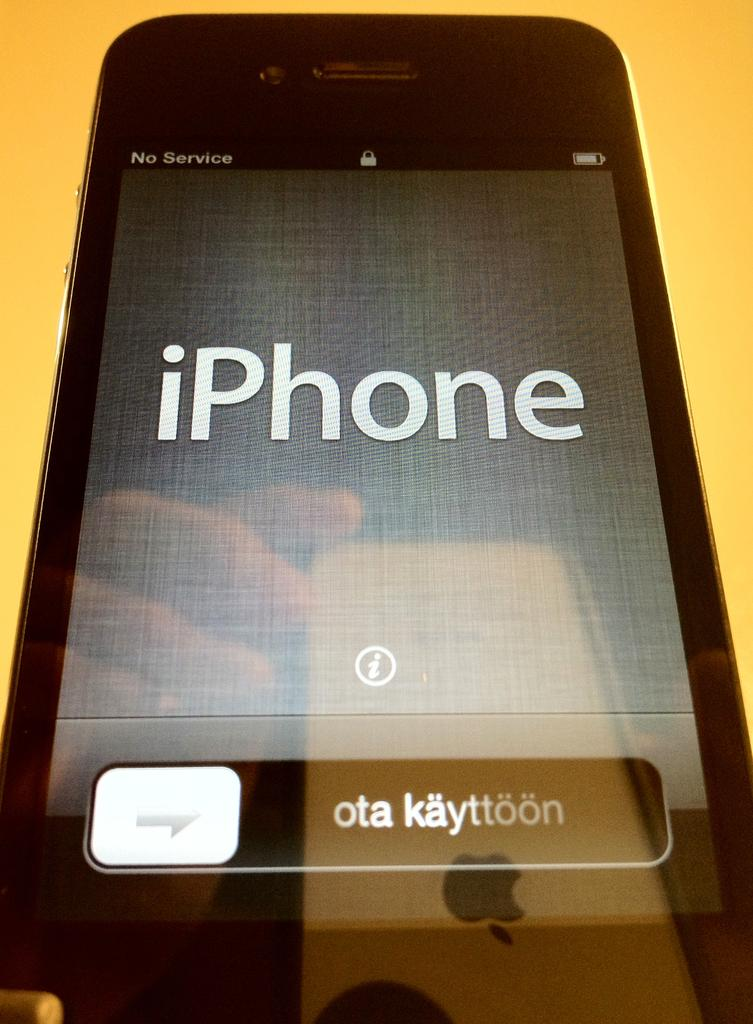<image>
Describe the image concisely. a black iphone on top of a yellow background 